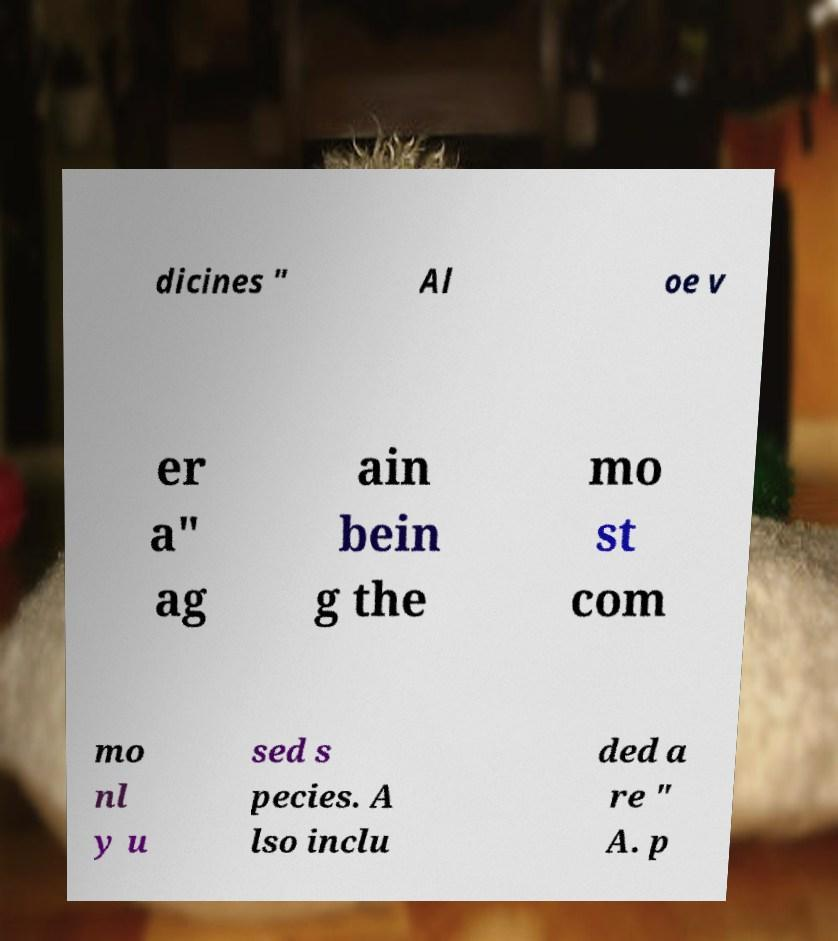Please read and relay the text visible in this image. What does it say? dicines " Al oe v er a" ag ain bein g the mo st com mo nl y u sed s pecies. A lso inclu ded a re " A. p 